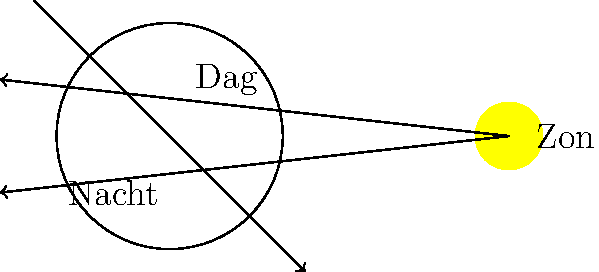Bekijk de afbeelding van de aarde en de zon. Als een specifiek punt op het aardoppervlak een volledige rotatie maakt van de dagzijde naar de nachtzijde en weer terug, hoeveel tijd is er dan ongeveer verstreken? Hoe noemen we deze tijdsperiode? Om deze vraag te beantwoorden, moeten we de volgende stappen volgen:

1. Begrijp de rotatie van de aarde:
   - De aarde draait om haar eigen as van west naar oost.
   - Deze rotatie veroorzaakt de afwisseling van dag en nacht.

2. Analyseer de afbeelding:
   - We zien de aarde met een dag- en nachtzijde.
   - De zon verlicht één helft van de aarde (dagzijde).

3. Denk na over de volledige rotatie:
   - Een punt op het aardoppervlak begint aan de dagzijde.
   - Het draait door de nachtzijde.
   - Het keert terug naar de oorspronkelijke positie aan de dagzijde.

4. Bepaal de tijdsduur:
   - Deze volledige rotatie duurt ongeveer 24 uur.
   - We noemen deze periode een dag of een etmaal.

5. Historische context (voor de geschiedenisleraar):
   - Het begrip van de aardrotatie en de dag-nachtcyclus heeft zich over duizenden jaren ontwikkeld.
   - Oude beschavingen, zoals de Egyptenaren en Babyloniërs, hadden al systemen om de tijd te meten op basis van deze cyclus.
   - De precieze meting van 24 uur voor een dag werd pas later vastgesteld met de ontwikkeling van nauwkeurigere tijdmeetinstrumenten.
Answer: 24 uur; een dag of etmaal 